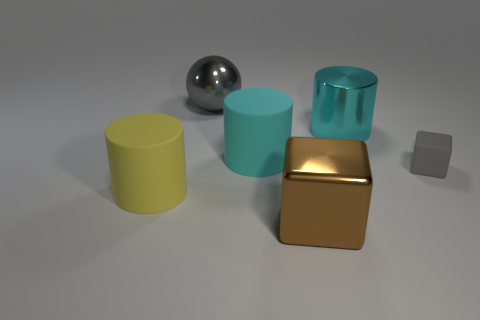What is the size of the thing that is in front of the cyan metallic cylinder and to the right of the large brown cube? The item in question appears to be a small grey cube, situated in front of the cyan cylinder and to the immediate right of the larger brown cube. Its size is significantly smaller compared to the other objects in the scene. 